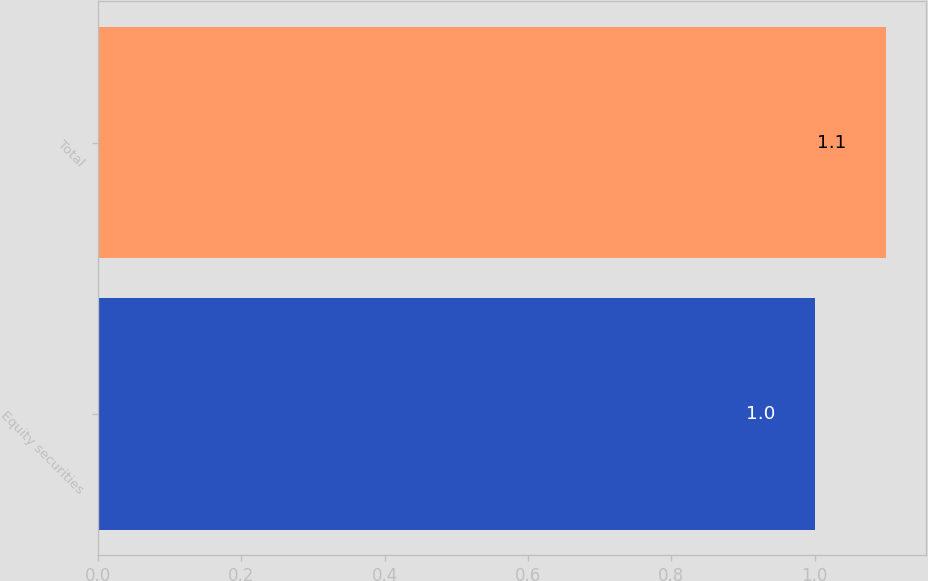Convert chart to OTSL. <chart><loc_0><loc_0><loc_500><loc_500><bar_chart><fcel>Equity securities<fcel>Total<nl><fcel>1<fcel>1.1<nl></chart> 